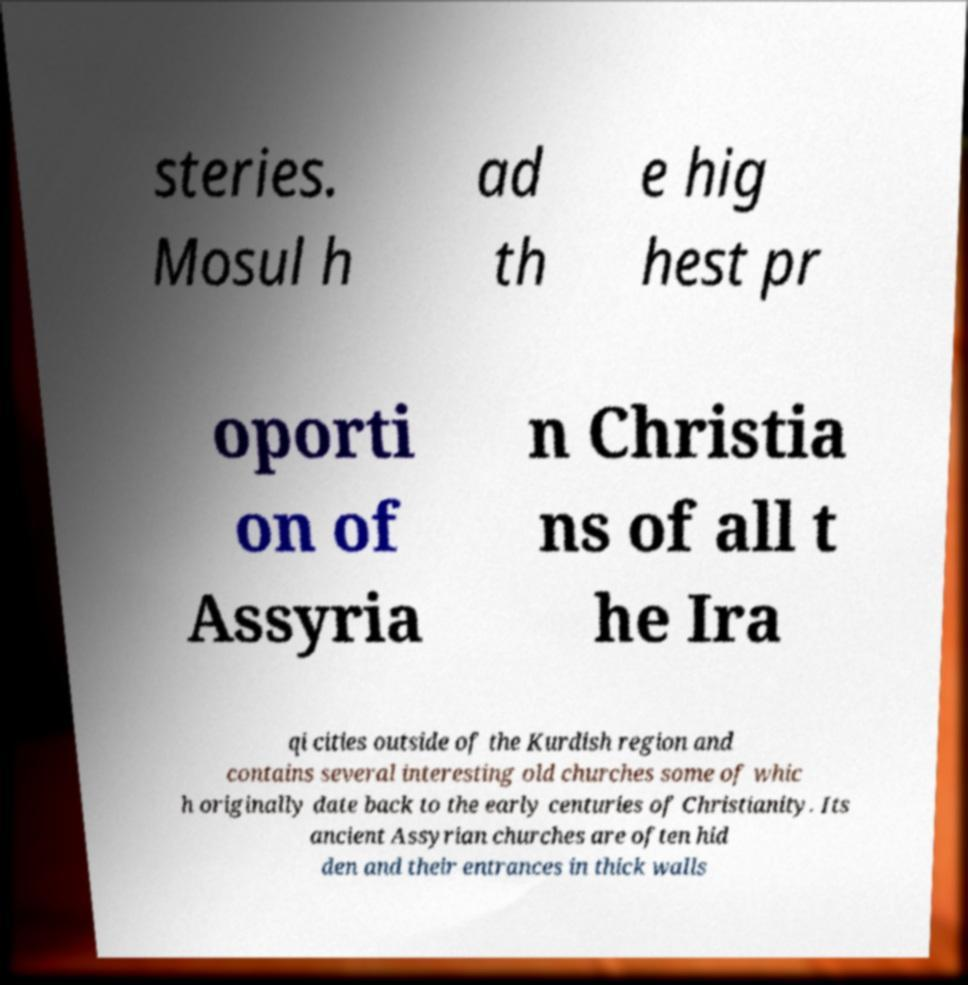Can you read and provide the text displayed in the image?This photo seems to have some interesting text. Can you extract and type it out for me? steries. Mosul h ad th e hig hest pr oporti on of Assyria n Christia ns of all t he Ira qi cities outside of the Kurdish region and contains several interesting old churches some of whic h originally date back to the early centuries of Christianity. Its ancient Assyrian churches are often hid den and their entrances in thick walls 